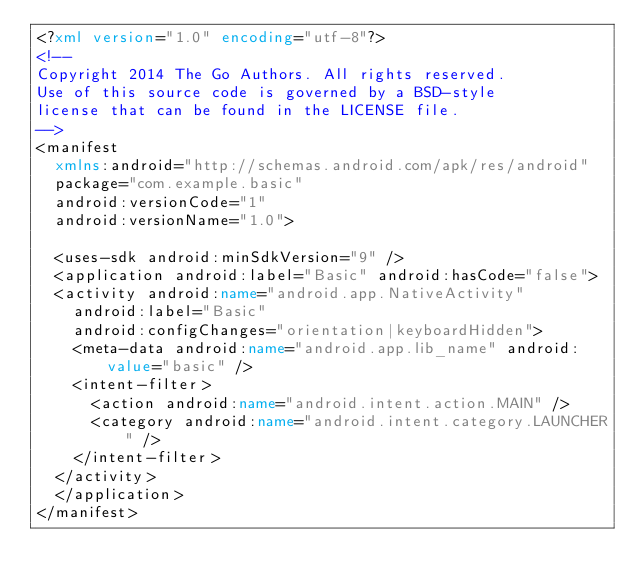<code> <loc_0><loc_0><loc_500><loc_500><_XML_><?xml version="1.0" encoding="utf-8"?>
<!--
Copyright 2014 The Go Authors. All rights reserved.
Use of this source code is governed by a BSD-style
license that can be found in the LICENSE file.
-->
<manifest
	xmlns:android="http://schemas.android.com/apk/res/android"
	package="com.example.basic"
	android:versionCode="1"
	android:versionName="1.0">

	<uses-sdk android:minSdkVersion="9" />
	<application android:label="Basic" android:hasCode="false">
	<activity android:name="android.app.NativeActivity"
		android:label="Basic"
		android:configChanges="orientation|keyboardHidden">
		<meta-data android:name="android.app.lib_name" android:value="basic" />
		<intent-filter>
			<action android:name="android.intent.action.MAIN" />
			<category android:name="android.intent.category.LAUNCHER" />
		</intent-filter>
	</activity>
	</application>
</manifest> 
</code> 